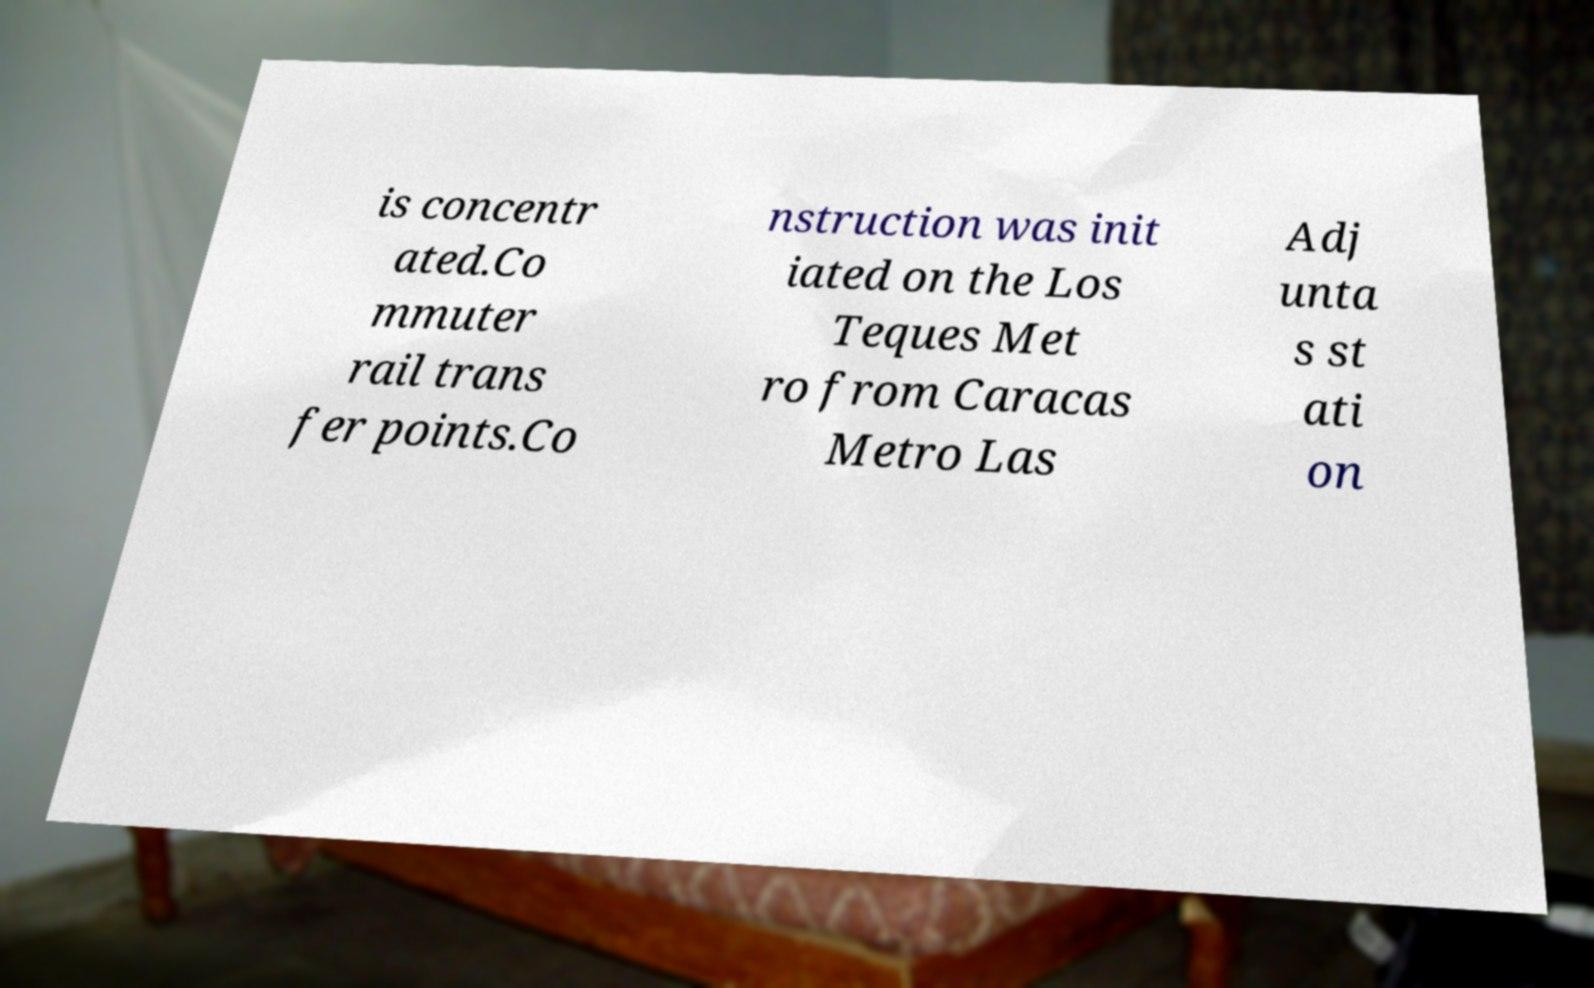Please identify and transcribe the text found in this image. is concentr ated.Co mmuter rail trans fer points.Co nstruction was init iated on the Los Teques Met ro from Caracas Metro Las Adj unta s st ati on 